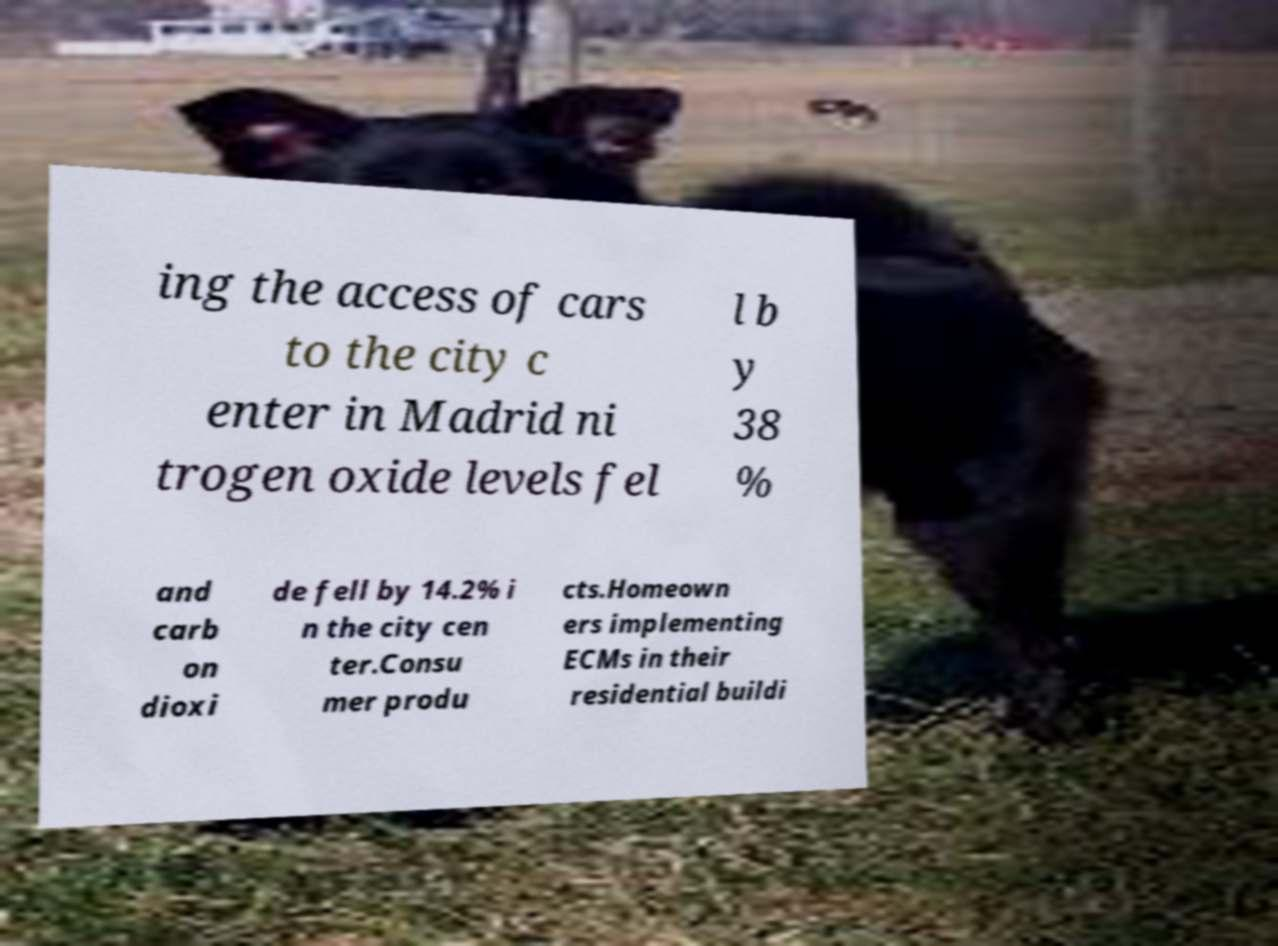Please identify and transcribe the text found in this image. ing the access of cars to the city c enter in Madrid ni trogen oxide levels fel l b y 38 % and carb on dioxi de fell by 14.2% i n the city cen ter.Consu mer produ cts.Homeown ers implementing ECMs in their residential buildi 